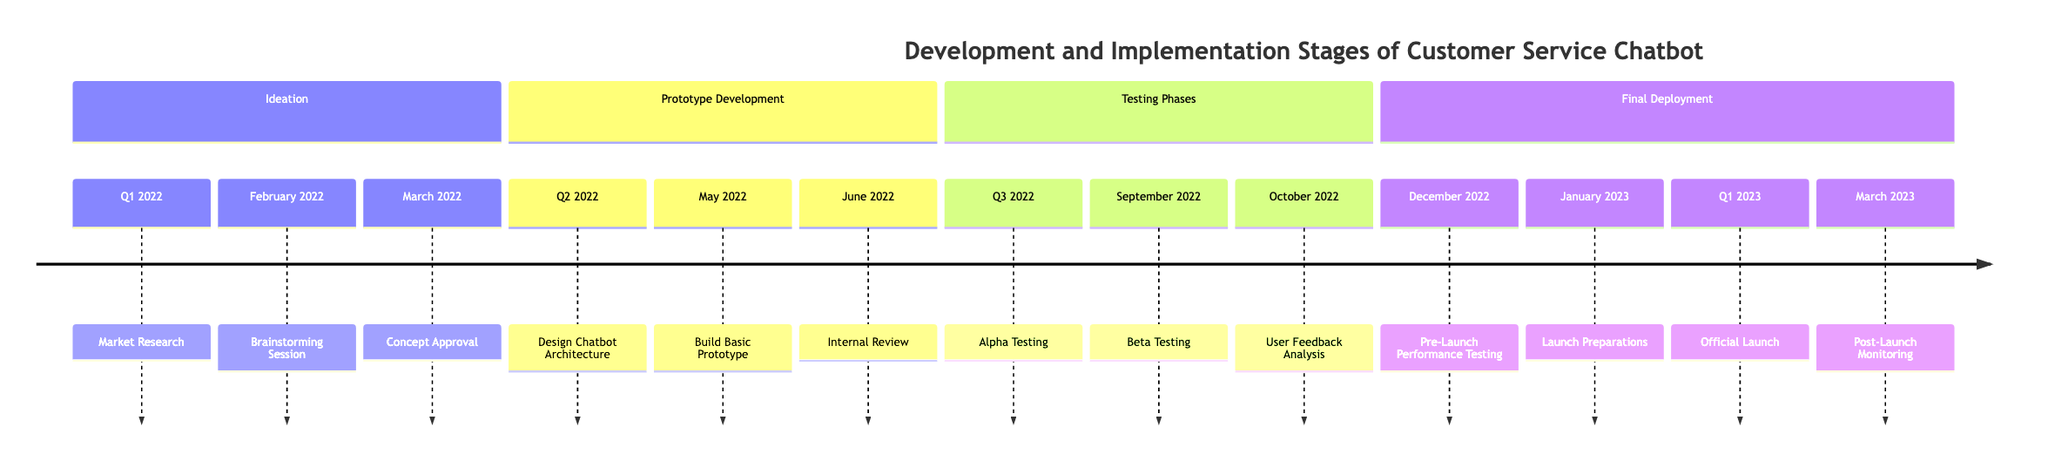What is the first milestone in the Ideation stage? The first milestone listed under the Ideation stage is "Market Research," which is dated Q1 2022.
Answer: Market Research How many milestones are in the Prototype Development stage? The Prototype Development stage contains three milestones: "Design Chatbot Architecture," "Build Basic Prototype," and "Internal Review."
Answer: 3 What milestone directly follows Beta Testing? The milestone that follows Beta Testing is "User Feedback Analysis," which occurs in October 2022.
Answer: User Feedback Analysis Which stage includes the Official Launch milestone? The Official Launch milestone is part of the Final Deployment stage.
Answer: Final Deployment What is the date of the Pre-Launch Performance Testing? The Pre-Launch Performance Testing milestone is scheduled for December 2022.
Answer: December 2022 What is the duration between the Concept Approval and the Build Basic Prototype? The Concept Approval took place in March 2022, and the Build Basic Prototype began in May 2022; hence, the duration is approximately two months.
Answer: 2 months Name the last milestone in the timeline. The last milestone recorded in the timeline is "Post-Launch Monitoring," which is scheduled for March 2023.
Answer: Post-Launch Monitoring In which quarter does the Alpha Testing occur? The Alpha Testing occurs in Q3 2022.
Answer: Q3 2022 How many total stages are present in the timeline? The timeline includes four distinct stages: Ideation, Prototype Development, Testing Phases, and Final Deployment.
Answer: 4 